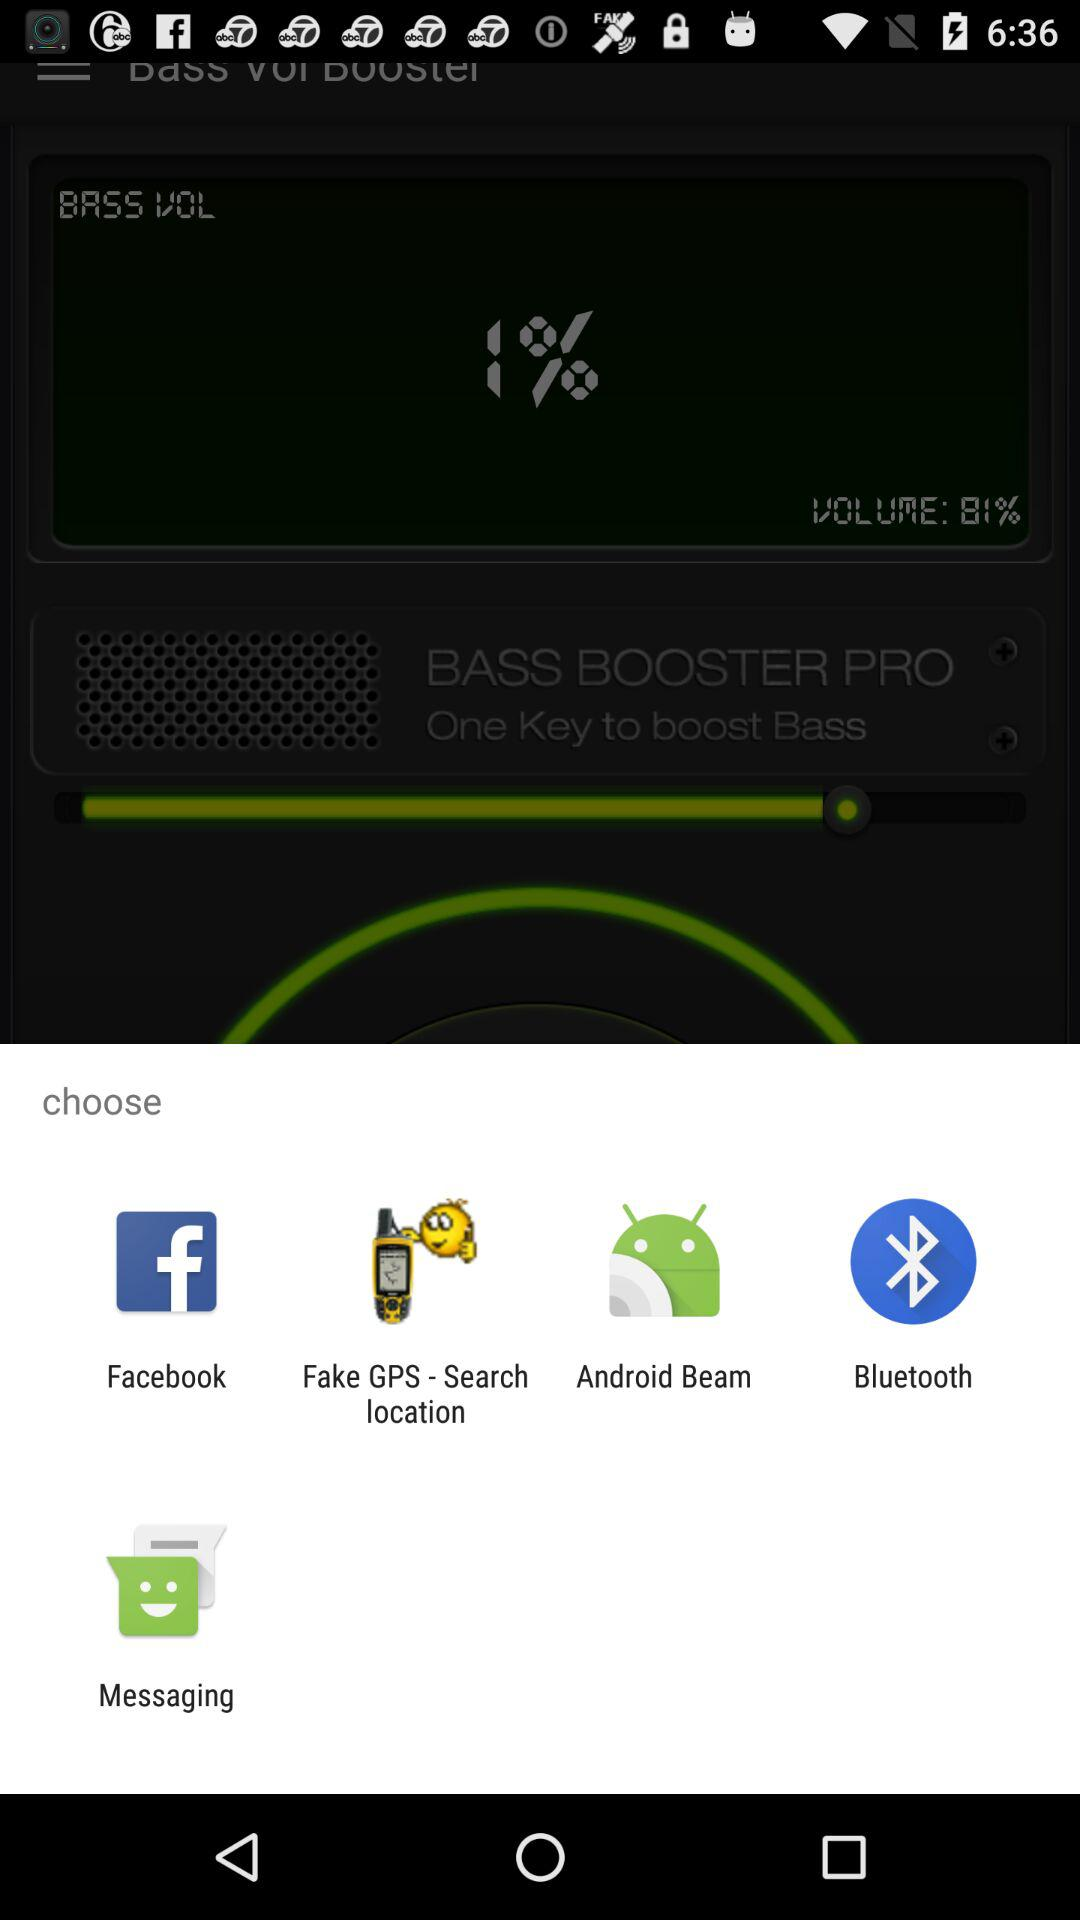Which app to choose to share? The apps are "Facebook", "Fake GPS - Search location", "Android Beam", "Bluetooth" and "Messaging". 